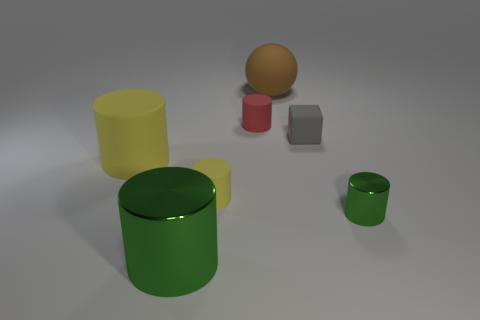Can you describe the textures of the objects, and guess what materials they might represent? The objects in the image have a smooth, somewhat reflective texture. The green and small yellow cylinders could be made of a glossy, painted metal due to their sheen and reflections. The red cylinder also has a glossy texture which suggests it could be ceramic. The medium gray cube has a matte finish, possibly indicating a rubber material, and the orange-brown sphere, with its shinier texture, could represent a polished wooden or plastic material. 